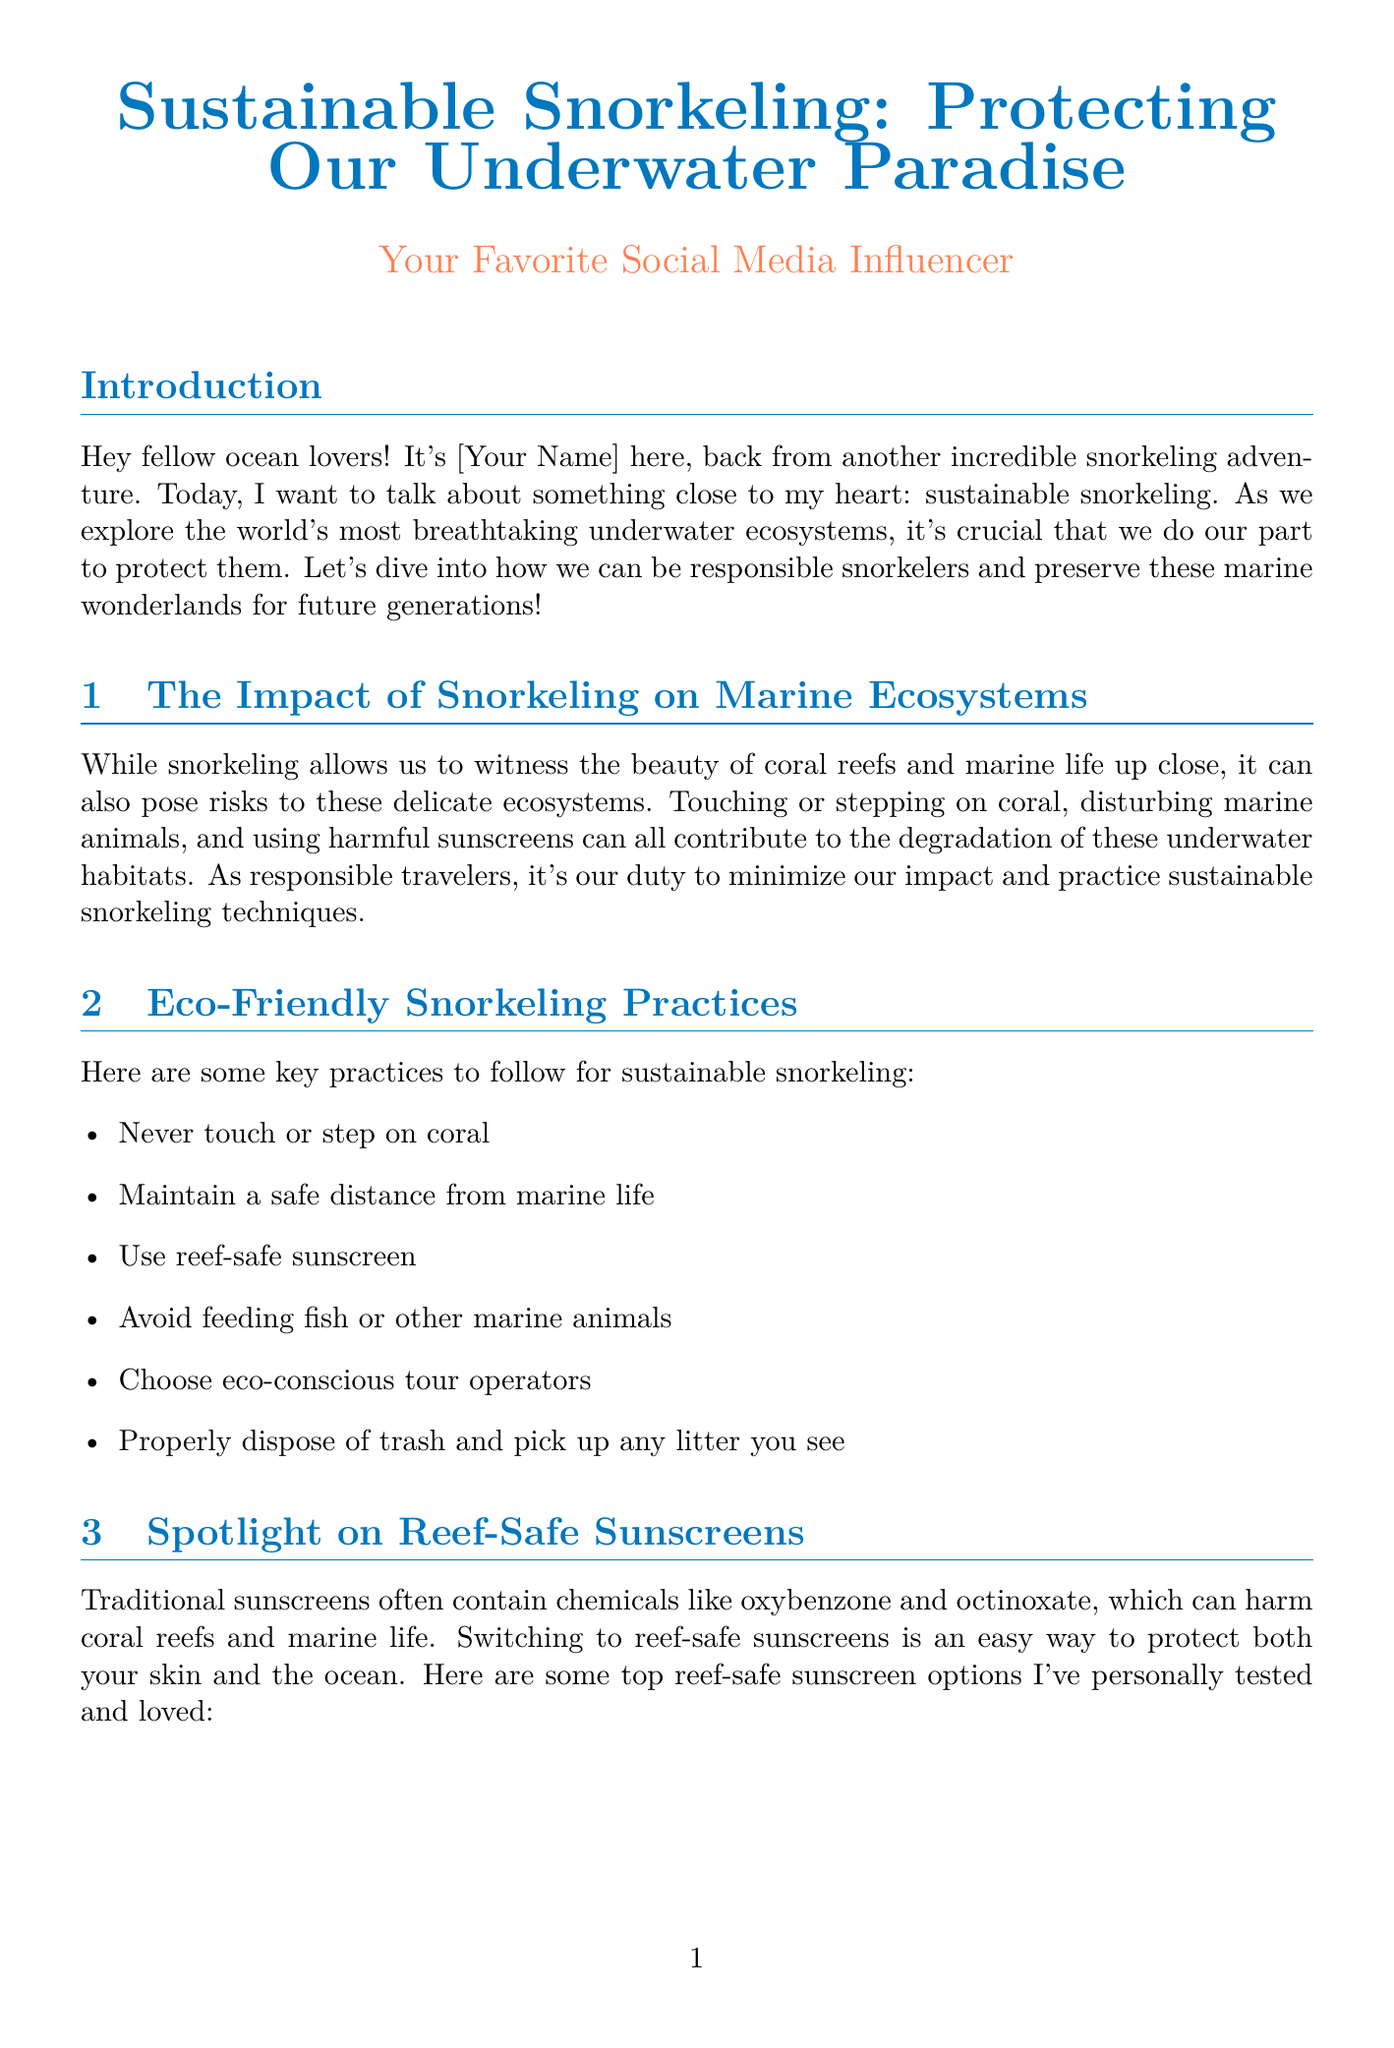What is the title of the newsletter? The title of the newsletter is at the top of the document and highlights the main topic being discussed.
Answer: Sustainable Snorkeling: Protecting Our Underwater Paradise Who is the author of the newsletter? The author is mentioned at the beginning of the document to identify the influencer sharing their experiences.
Answer: Your Favorite Social Media Influencer What is one harmful ingredient commonly found in traditional sunscreens? The document lists some harmful chemicals in sunscreens that affect marine life, and oxybenzone is one of them.
Answer: Oxybenzone How many steps are outlined for sustainable snorkeling? The infographic section provides a clear enumeration of the steps to follow for sustainability while snorkeling.
Answer: 5 What feature is highlighted for the Stream2Sea Sport Sunscreen? Details are provided about different reef-safe sunscreens and their key attributes for selection.
Answer: Water-resistant and biodegradable What is an eco-friendly practice suggested for snorkeling? The document offers several practices to minimize impact while snorkeling, one of which involves not disturbing the coral.
Answer: Never touch or step on coral Which sunscreen has the highest SPF listed? The comparison table presents various sunscreens along with their SPF ratings, showing which is the highest.
Answer: 50 What material is the Fourth Element OceanPositive Mask made from? Examples of sustainable snorkeling gear are provided, along with the materials they are made of for environmental consideration.
Answer: Recycled ghost fishing nets 